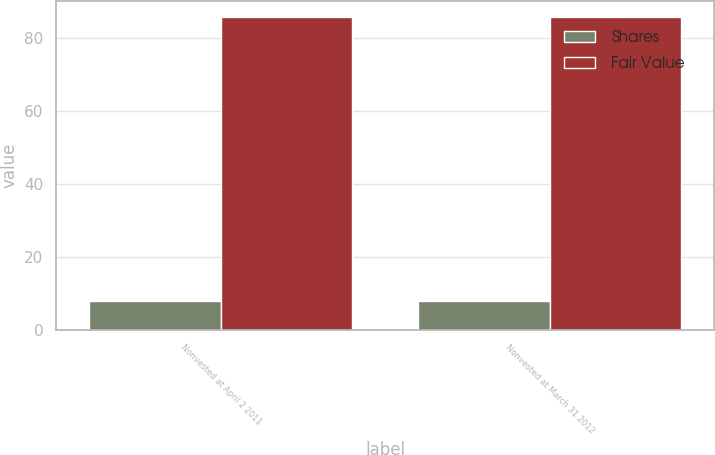Convert chart. <chart><loc_0><loc_0><loc_500><loc_500><stacked_bar_chart><ecel><fcel>Nonvested at April 2 2011<fcel>Nonvested at March 31 2012<nl><fcel>Shares<fcel>8<fcel>8<nl><fcel>Fair Value<fcel>85.87<fcel>85.87<nl></chart> 